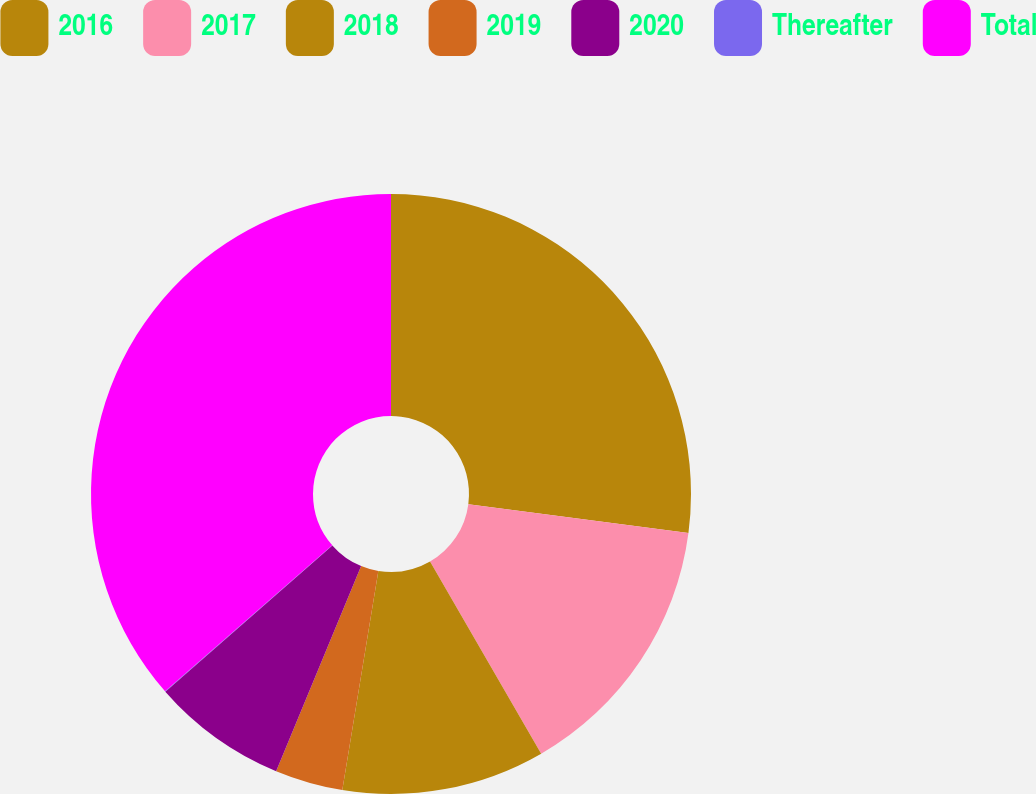Convert chart to OTSL. <chart><loc_0><loc_0><loc_500><loc_500><pie_chart><fcel>2016<fcel>2017<fcel>2018<fcel>2019<fcel>2020<fcel>Thereafter<fcel>Total<nl><fcel>27.08%<fcel>14.58%<fcel>10.94%<fcel>3.66%<fcel>7.3%<fcel>0.02%<fcel>36.43%<nl></chart> 